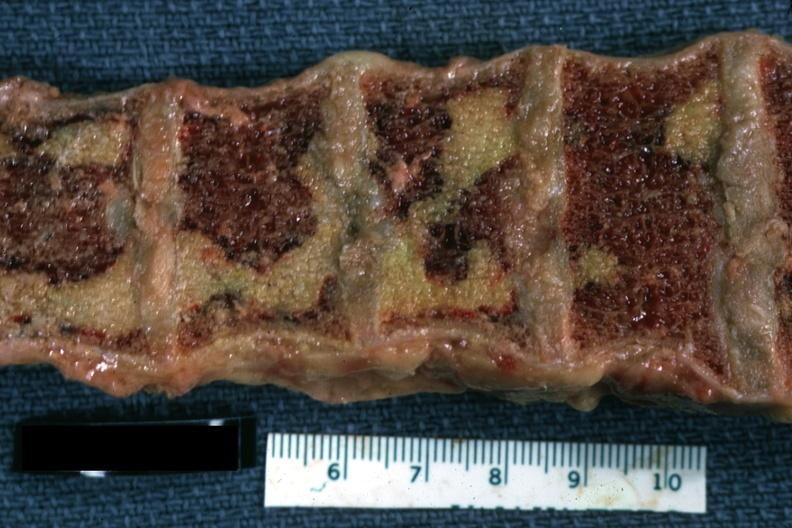what is present?
Answer the question using a single word or phrase. Joints 